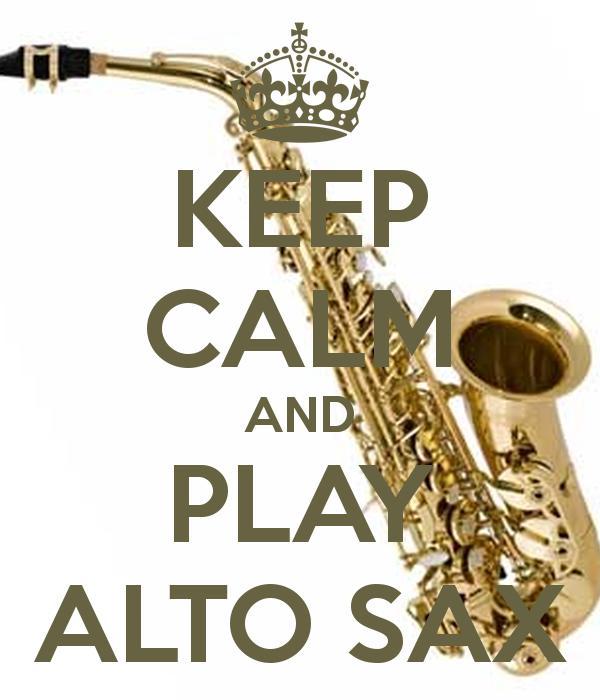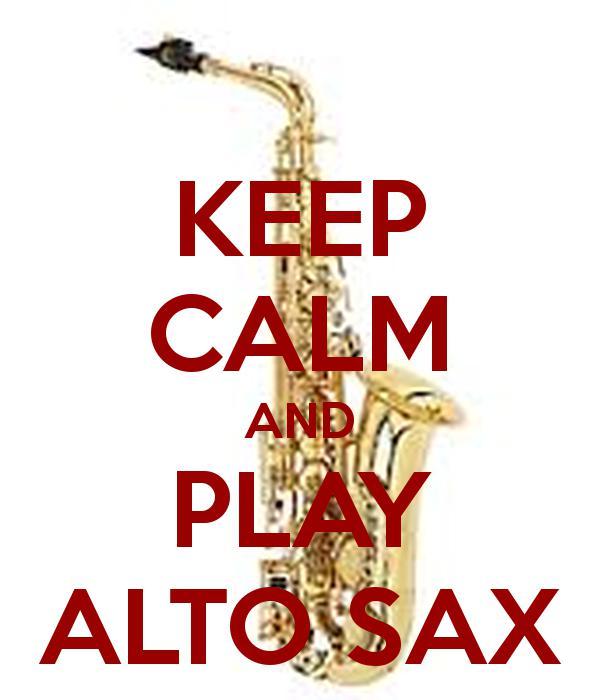The first image is the image on the left, the second image is the image on the right. Analyze the images presented: Is the assertion "One saxophone is displayed vertically, and the other is displayed at an angle with the bell-side upturned and the mouthpiece at the upper left." valid? Answer yes or no. Yes. The first image is the image on the left, the second image is the image on the right. For the images shown, is this caption "The saxophone on the left is standing straight up and down." true? Answer yes or no. No. 